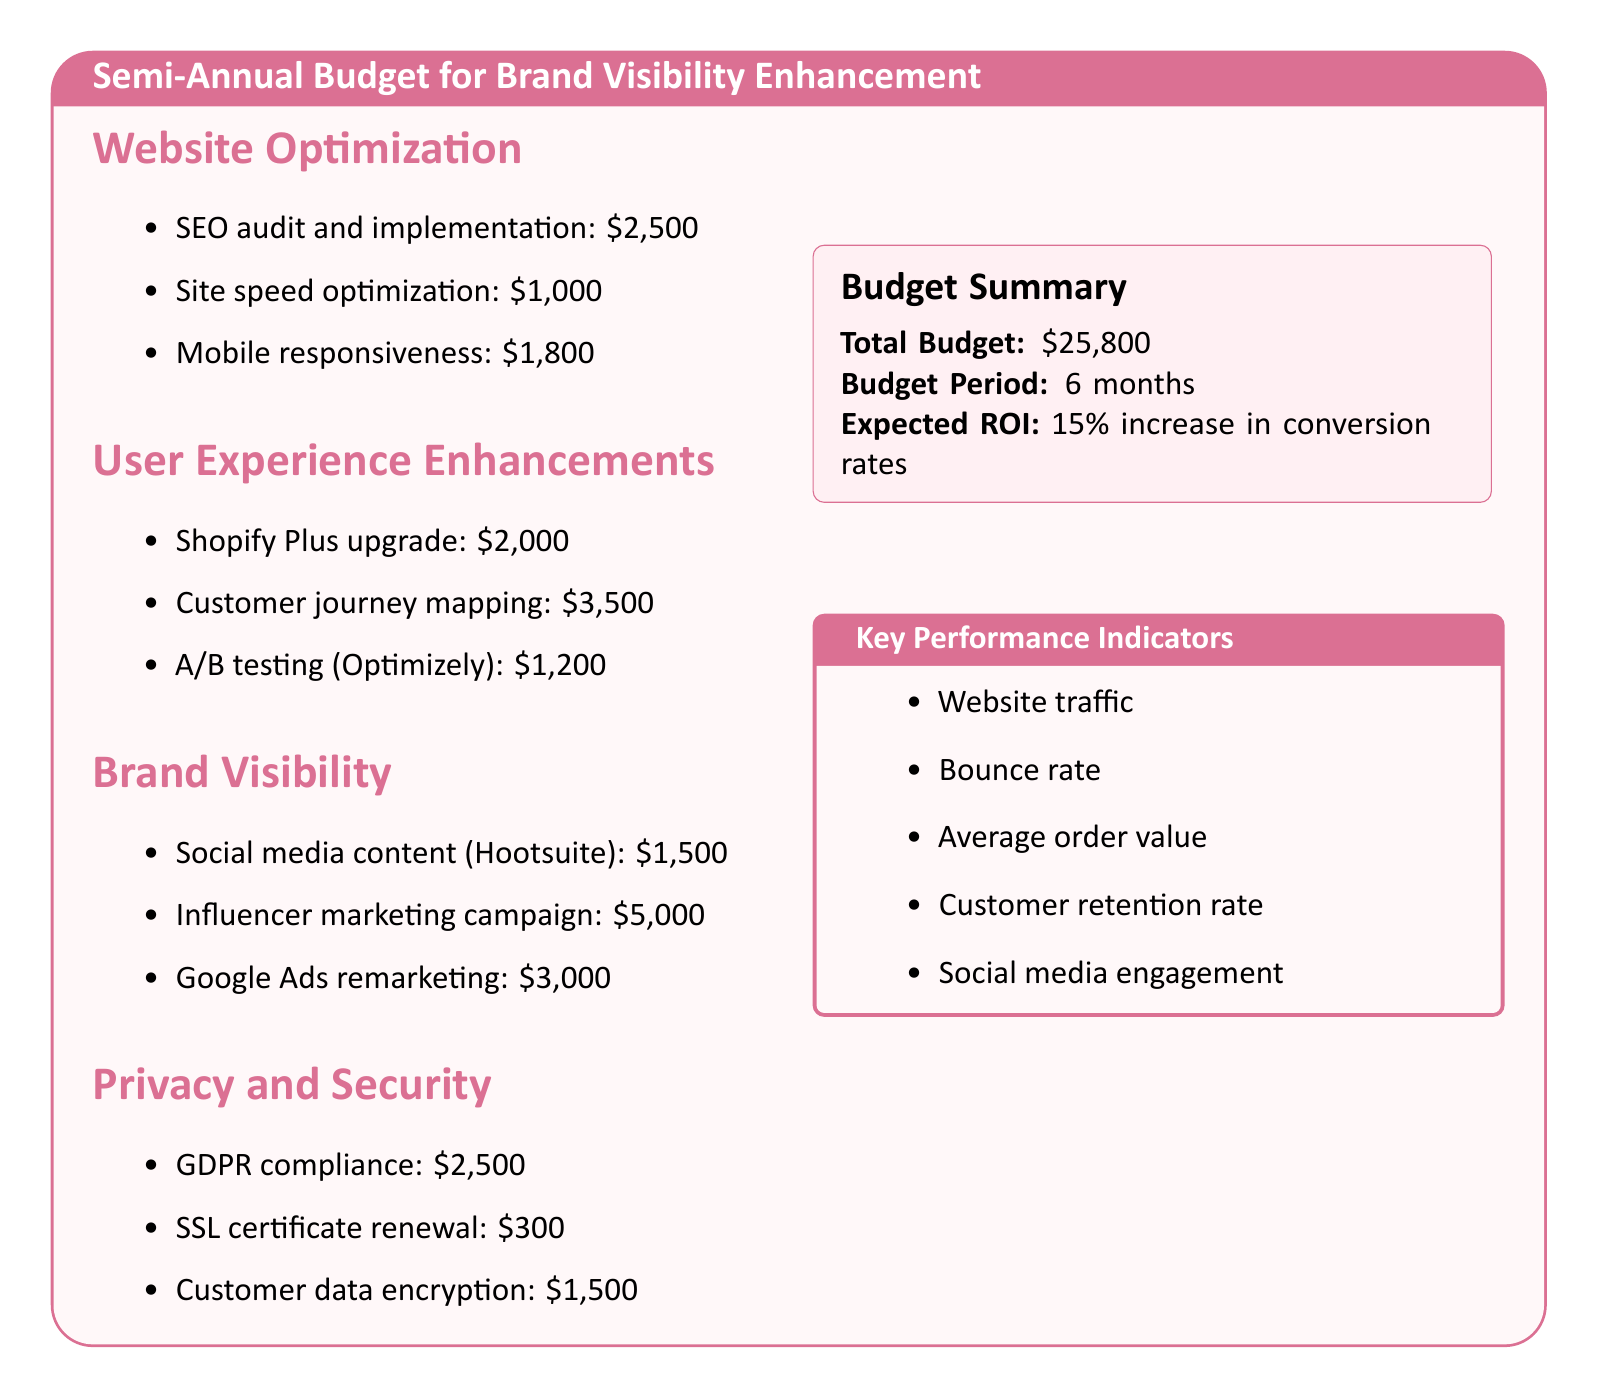What is the total budget? The total budget is listed in the summary section of the document.
Answer: $25,800 How much is allocated for SEO audit and implementation? The amount for SEO audit and implementation is found under the Website Optimization section.
Answer: $2,500 How much is the budget for the Influencer marketing campaign? The budget for the Influencer marketing campaign is mentioned in the Brand Visibility section.
Answer: $5,000 What is the expected ROI? The expected ROI is provided in the budget summary section.
Answer: 15 percent increase in conversion rates How much is allocated for customer journey mapping? The amount for customer journey mapping can be found in the User Experience Enhancements section.
Answer: $3,500 What does GDPR compliance cost? The cost for GDPR compliance is listed under the Privacy and Security section.
Answer: $2,500 Which tool is mentioned for A/B testing? The tool for A/B testing is identified under User Experience Enhancements.
Answer: Optimizely What are the key performance indicators listed? The key performance indicators are specified in the Key Performance Indicators section of the document.
Answer: Website traffic, Bounce rate, Average order value, Customer retention rate, Social media engagement How much is the budget for Google Ads remarketing? The budget for Google Ads remarketing is included in the Brand Visibility section.
Answer: $3,000 